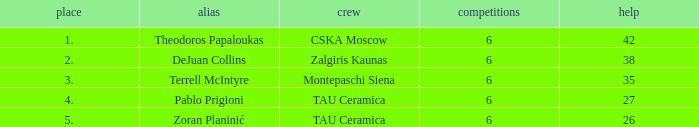What is the least number of assists among players ranked 2? 38.0. Can you give me this table as a dict? {'header': ['place', 'alias', 'crew', 'competitions', 'help'], 'rows': [['1.', 'Theodoros Papaloukas', 'CSKA Moscow', '6', '42'], ['2.', 'DeJuan Collins', 'Zalgiris Kaunas', '6', '38'], ['3.', 'Terrell McIntyre', 'Montepaschi Siena', '6', '35'], ['4.', 'Pablo Prigioni', 'TAU Ceramica', '6', '27'], ['5.', 'Zoran Planinić', 'TAU Ceramica', '6', '26']]} 